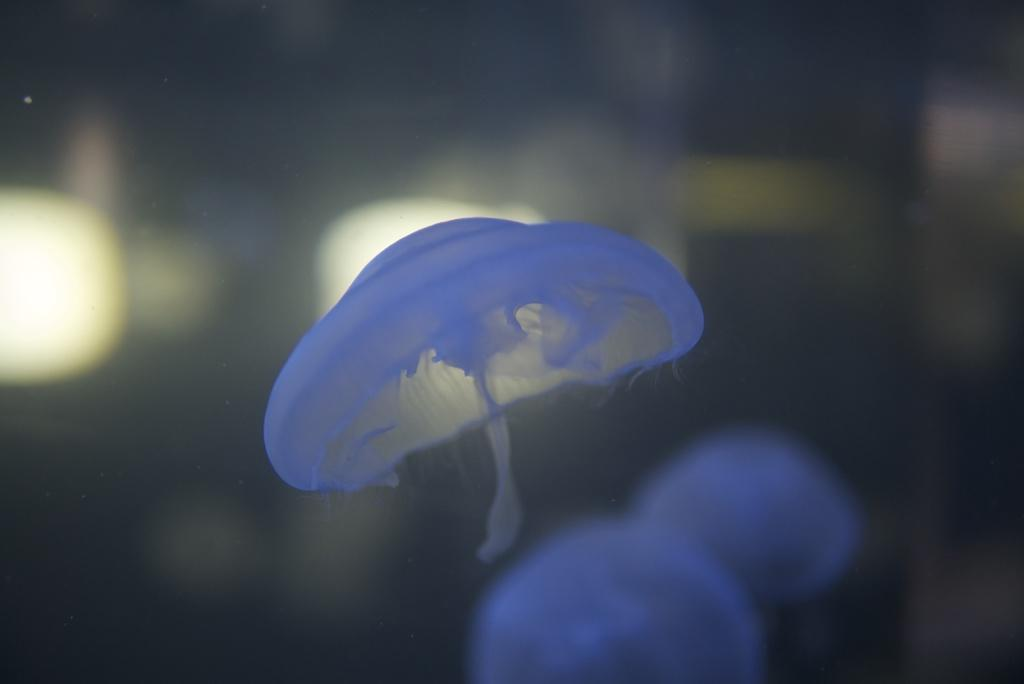What type of sea creatures are in the image? There are jellyfish in the image. What color are the jellyfish? The jellyfish are blue in color. Can you describe the background of the image? The background of the image is blurred. What type of copy machine can be seen in the image? There is no copy machine present in the image; it features jellyfish. What type of front door can be seen in the image? There is no front door present in the image; it features jellyfish. 